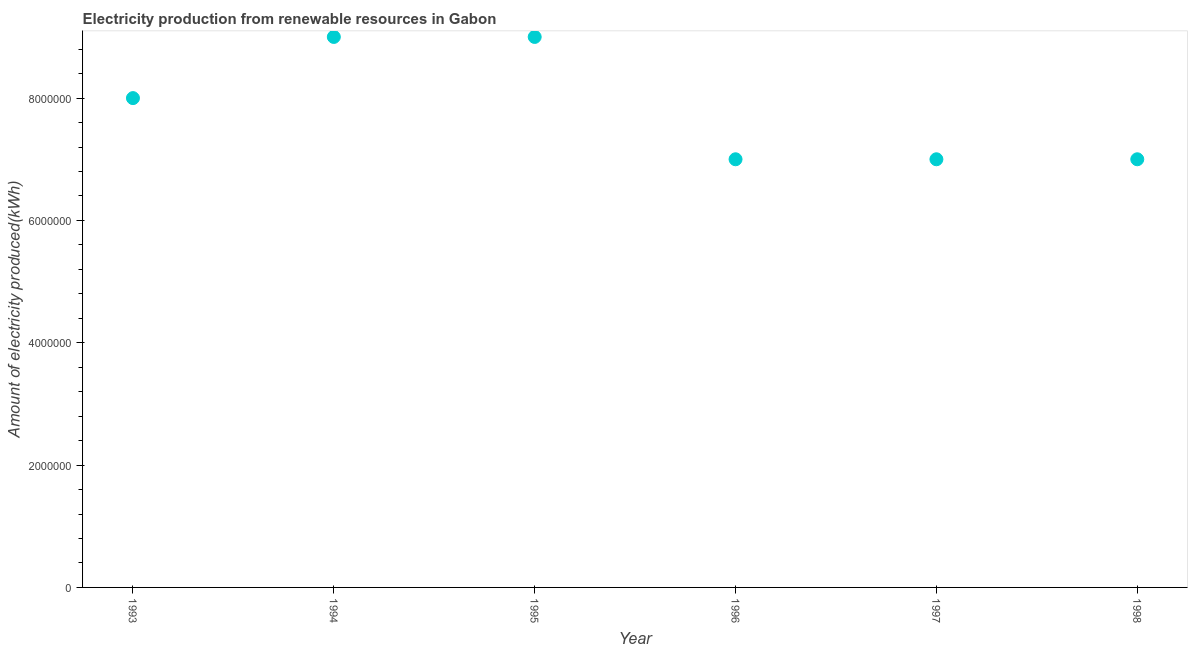What is the amount of electricity produced in 1994?
Provide a succinct answer. 9.00e+06. Across all years, what is the maximum amount of electricity produced?
Offer a very short reply. 9.00e+06. Across all years, what is the minimum amount of electricity produced?
Keep it short and to the point. 7.00e+06. In which year was the amount of electricity produced maximum?
Make the answer very short. 1994. In which year was the amount of electricity produced minimum?
Provide a succinct answer. 1996. What is the sum of the amount of electricity produced?
Your answer should be very brief. 4.70e+07. What is the difference between the amount of electricity produced in 1993 and 1996?
Give a very brief answer. 1.00e+06. What is the average amount of electricity produced per year?
Offer a very short reply. 7.83e+06. What is the median amount of electricity produced?
Offer a terse response. 7.50e+06. In how many years, is the amount of electricity produced greater than 5200000 kWh?
Provide a succinct answer. 6. Do a majority of the years between 1997 and 1994 (inclusive) have amount of electricity produced greater than 2000000 kWh?
Keep it short and to the point. Yes. What is the ratio of the amount of electricity produced in 1995 to that in 1997?
Keep it short and to the point. 1.29. Is the sum of the amount of electricity produced in 1993 and 1994 greater than the maximum amount of electricity produced across all years?
Provide a succinct answer. Yes. What is the difference between the highest and the lowest amount of electricity produced?
Offer a terse response. 2.00e+06. In how many years, is the amount of electricity produced greater than the average amount of electricity produced taken over all years?
Offer a terse response. 3. Does the amount of electricity produced monotonically increase over the years?
Offer a terse response. No. What is the difference between two consecutive major ticks on the Y-axis?
Offer a terse response. 2.00e+06. Does the graph contain any zero values?
Offer a very short reply. No. What is the title of the graph?
Offer a terse response. Electricity production from renewable resources in Gabon. What is the label or title of the Y-axis?
Make the answer very short. Amount of electricity produced(kWh). What is the Amount of electricity produced(kWh) in 1994?
Offer a terse response. 9.00e+06. What is the Amount of electricity produced(kWh) in 1995?
Ensure brevity in your answer.  9.00e+06. What is the Amount of electricity produced(kWh) in 1996?
Provide a short and direct response. 7.00e+06. What is the difference between the Amount of electricity produced(kWh) in 1993 and 1996?
Keep it short and to the point. 1.00e+06. What is the difference between the Amount of electricity produced(kWh) in 1993 and 1998?
Provide a short and direct response. 1.00e+06. What is the difference between the Amount of electricity produced(kWh) in 1994 and 1996?
Offer a terse response. 2.00e+06. What is the difference between the Amount of electricity produced(kWh) in 1994 and 1997?
Provide a short and direct response. 2.00e+06. What is the difference between the Amount of electricity produced(kWh) in 1994 and 1998?
Give a very brief answer. 2.00e+06. What is the difference between the Amount of electricity produced(kWh) in 1995 and 1996?
Your answer should be very brief. 2.00e+06. What is the difference between the Amount of electricity produced(kWh) in 1995 and 1997?
Your answer should be very brief. 2.00e+06. What is the ratio of the Amount of electricity produced(kWh) in 1993 to that in 1994?
Make the answer very short. 0.89. What is the ratio of the Amount of electricity produced(kWh) in 1993 to that in 1995?
Provide a short and direct response. 0.89. What is the ratio of the Amount of electricity produced(kWh) in 1993 to that in 1996?
Make the answer very short. 1.14. What is the ratio of the Amount of electricity produced(kWh) in 1993 to that in 1997?
Offer a terse response. 1.14. What is the ratio of the Amount of electricity produced(kWh) in 1993 to that in 1998?
Provide a succinct answer. 1.14. What is the ratio of the Amount of electricity produced(kWh) in 1994 to that in 1996?
Make the answer very short. 1.29. What is the ratio of the Amount of electricity produced(kWh) in 1994 to that in 1997?
Make the answer very short. 1.29. What is the ratio of the Amount of electricity produced(kWh) in 1994 to that in 1998?
Give a very brief answer. 1.29. What is the ratio of the Amount of electricity produced(kWh) in 1995 to that in 1996?
Keep it short and to the point. 1.29. What is the ratio of the Amount of electricity produced(kWh) in 1995 to that in 1997?
Your answer should be compact. 1.29. What is the ratio of the Amount of electricity produced(kWh) in 1995 to that in 1998?
Ensure brevity in your answer.  1.29. What is the ratio of the Amount of electricity produced(kWh) in 1996 to that in 1998?
Make the answer very short. 1. 